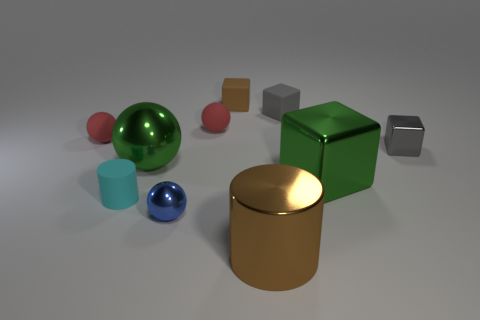Subtract 1 balls. How many balls are left? 3 Subtract all cylinders. How many objects are left? 8 Subtract all tiny brown rubber things. Subtract all large cylinders. How many objects are left? 8 Add 6 big brown objects. How many big brown objects are left? 7 Add 4 rubber things. How many rubber things exist? 9 Subtract 0 blue cylinders. How many objects are left? 10 